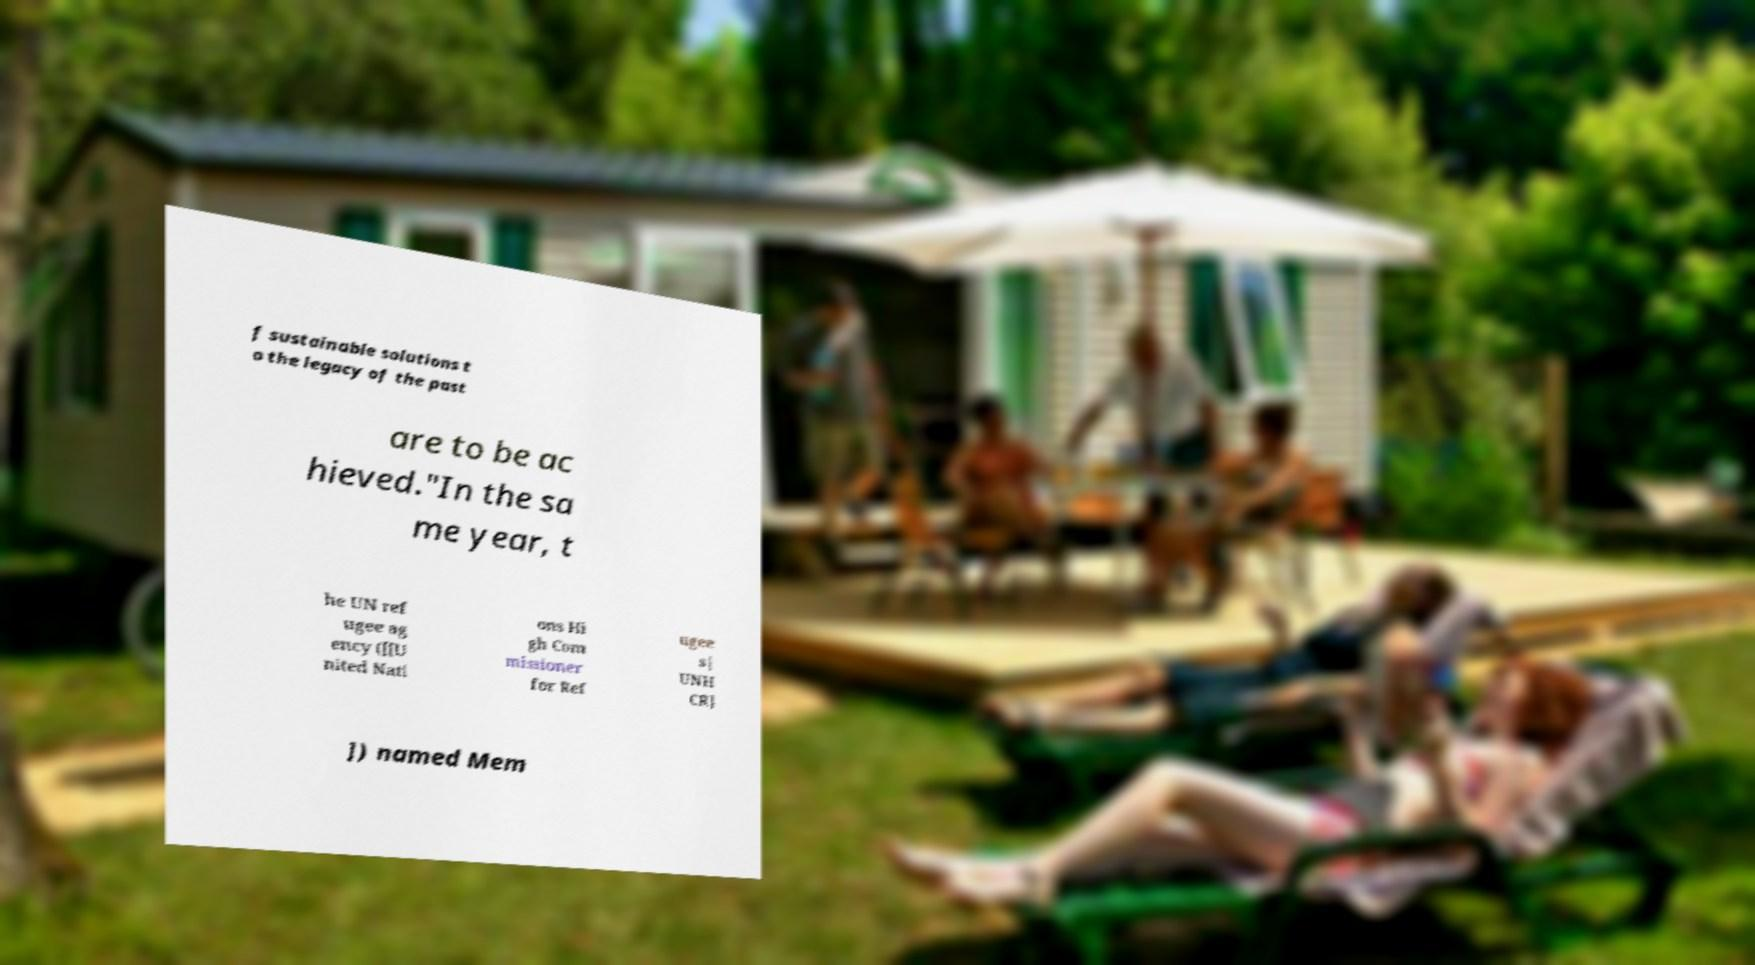Please identify and transcribe the text found in this image. f sustainable solutions t o the legacy of the past are to be ac hieved."In the sa me year, t he UN ref ugee ag ency ([[U nited Nati ons Hi gh Com missioner for Ref ugee s| UNH CR] ]) named Mem 